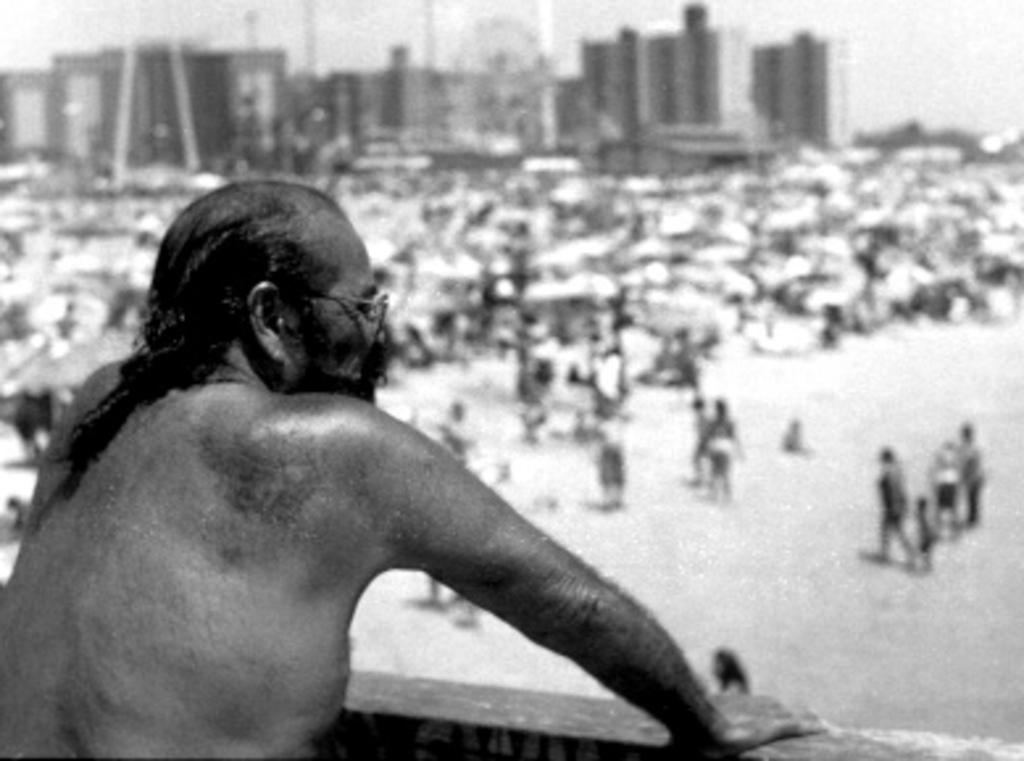Who is the main subject in the image? There is a man in the image. What is the man wearing in the image? The man is wearing spectacles in the image. What can be seen in the background of the image? There are people, buildings, and the sky visible in the background of the image. What is the color scheme of the image? The image is black and white in color. What type of unit can be seen in the man's mouth in the image? There is no unit visible in the man's mouth in the image. Does the man have a tail in the image? No, the man does not have a tail in the image. 